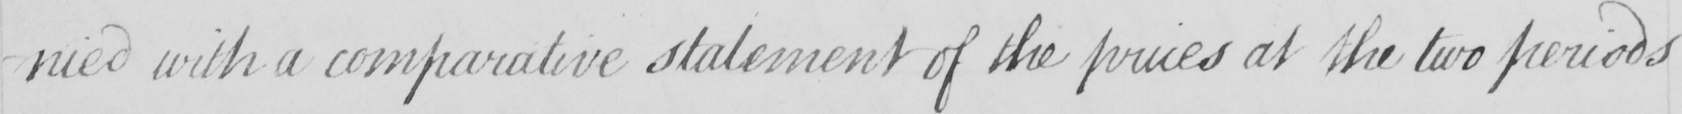What text is written in this handwritten line? -nied with a comparative statement of the prices at the two periods 